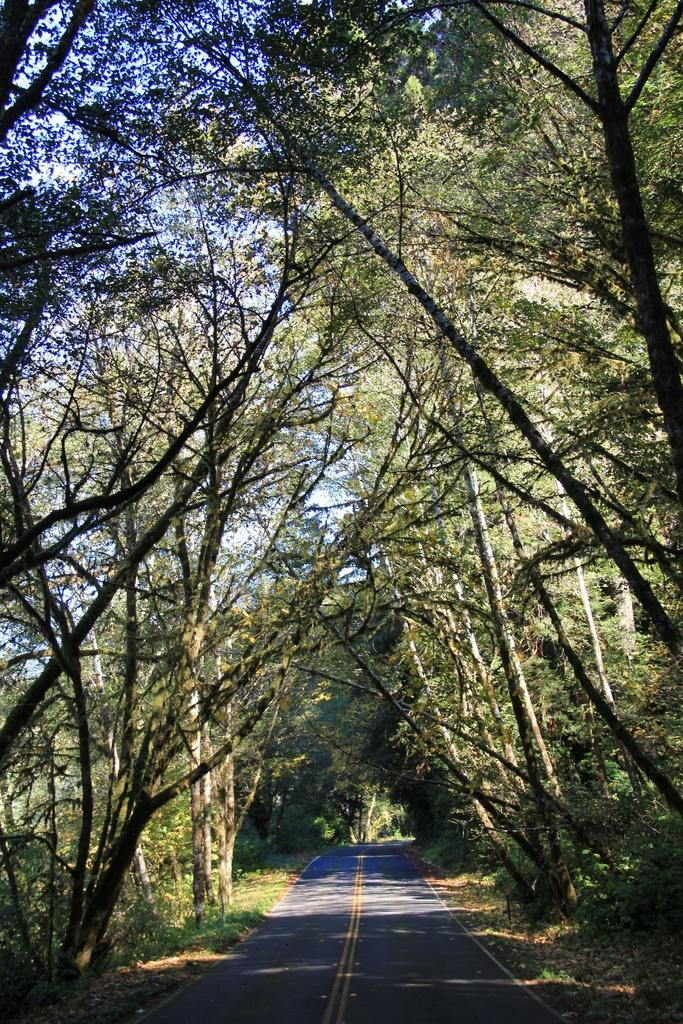What is the main subject of the image? The main subject of the image is a long road. What can be seen on both sides of the road? There are trees on either side of the road. How would you describe the sky in the image? The sky is bright in the image. What type of magic is being performed on the road in the image? There is no magic or any magical activity present in the image. Can you tell me how many drains are visible on the road in the image? There is no drain visible on the road in the image. 